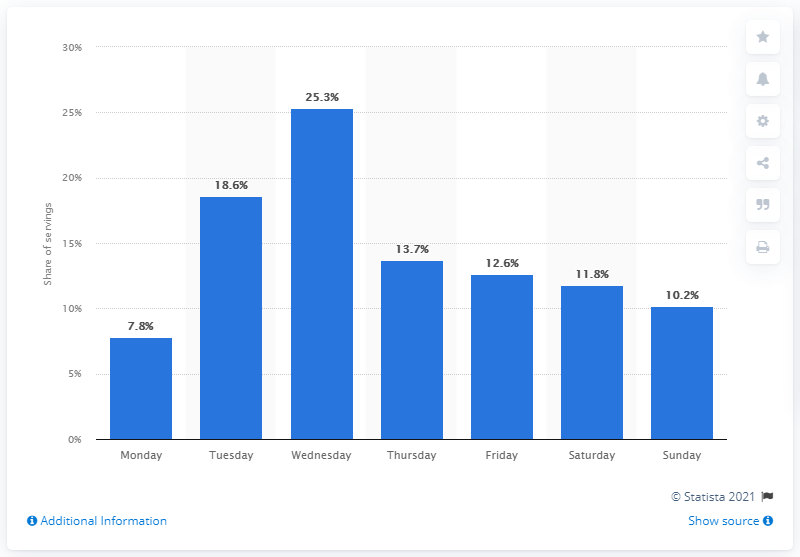Draw attention to some important aspects in this diagram. On Wednesday, the majority of fish and chips dishes were served. 